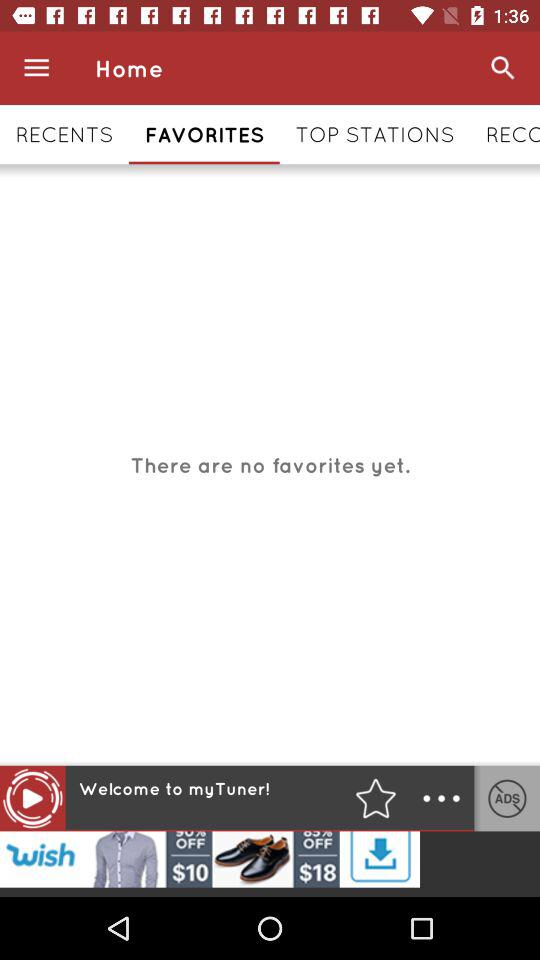How many favorites are there? There are no favorites. 